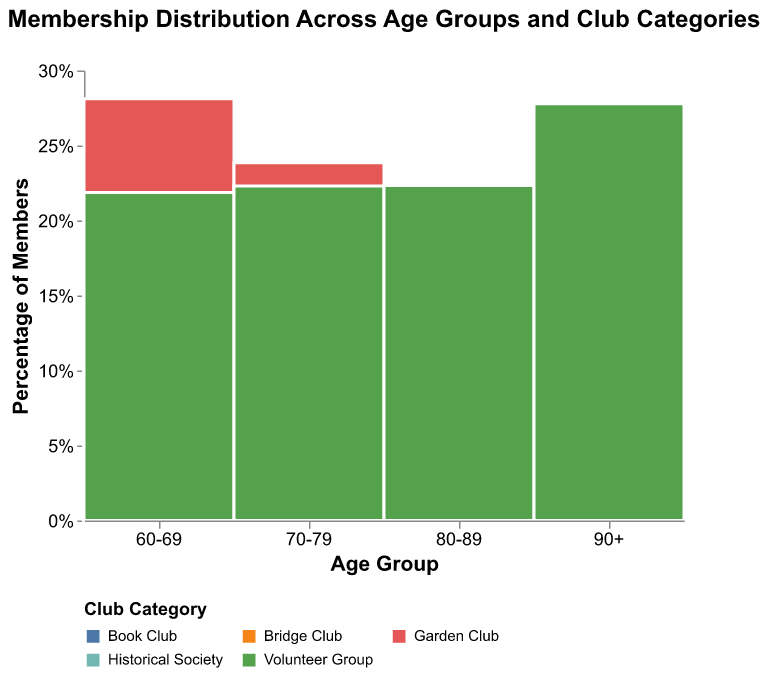Which age group has the highest membership percentage in the Garden Club? Look at the section of the mosaic plot corresponding to each age group and compare the Garden Club's relative height. The 70-79 age group has the highest proportion relative to other age groups.
Answer: 70-79 What percentage of the 90+ age group is in the Bridge Club? Locate the section of the mosaic plot for the 90+ age group and find the Bridge Club's segment. The tooltip indicates that this is approximately 26.3%.
Answer: 26.3% Which club category has the highest membership in the 80-89 age group? Look at the height of each segment within the 80-89 age group. The Club Category with the tallest segment relative to others in this age group is the Volunteer Group.
Answer: Volunteer Group What is the difference in membership percentage between the Book Club and the Bridge Club for the 70-79 age group? Find the segments for the Book Club and Bridge Club in the 70-79 age group. The Book Club segment is approximately 26.7%, and the Bridge Club segment is around 22.2%. The difference is 26.7% - 22.2% = 4.5%.
Answer: 4.5% Is the total membership of the Volunteer Group greater than that of the Historical Society? Sum the total memberships for each age group across the Volunteer Group and Historical Society. The Volunteer Group totals 35+58+42+25 = 160, and the Historical Society totals 28+52+40+18 = 138. Thus, the Volunteer Group has a higher total membership.
Answer: Yes What is the combined membership percentage of the Garden Club and the Book Club in the 60-69 age group? Add the percentages for the Garden Club (about 32%) and Book Club (about 21.3%) segments in the 60-69 age group. The combined percentage is about 32% + 21.3% = 53.3%.
Answer: 53.3% In the 70-79 age group, which club has the lowest membership percentage? Identify the shortest segment within the 70-79 age group. The Bridge Club has the lowest percentage, which is approximately 17.8%.
Answer: Bridge Club Which age group shows the least variation in membership percentages across all clubs? Visually compare the bar heights across all age groups. The 90+ age group shows the least variation, as its segments are more uniformly sized.
Answer: 90+ How does the membership of the Garden Club change from the 60-69 age group to the 90+ age group? Observe the relative height of the Garden Club segment as you move from 60-69 to 90+. The percentage decreases progressively.
Answer: Decreases What is the total number of members in the 80-89 age group for all clubs combined? Total the memberships recorded for each club in the 80-89 age group: Garden Club (38), Book Club (35), Historical Society (40), Bridge Club (33), Volunteer Group (42). Sum is 38+35+40+33+42 = 188.
Answer: 188 